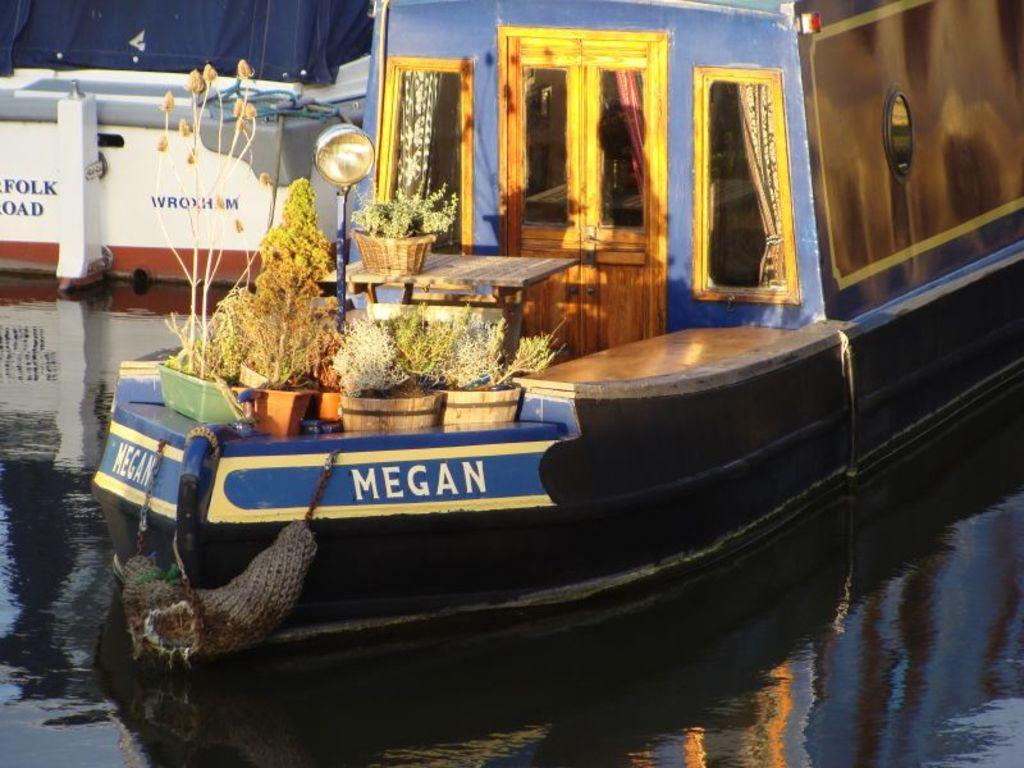What is the main subject of the image? The main subject of the image is a ship. Where is the ship located in the image? The ship is sailing on water. What items can be seen on the ship? There are flower pots, tables, and a pole on the ship. Can you describe the white-colored object in the image? Unfortunately, the facts provided do not mention a white-colored object. How many tickets does the expert on the ship have? There is no mention of an expert or tickets in the image. The image only features a ship sailing on water with flower pots, tables, and a pole on board. 